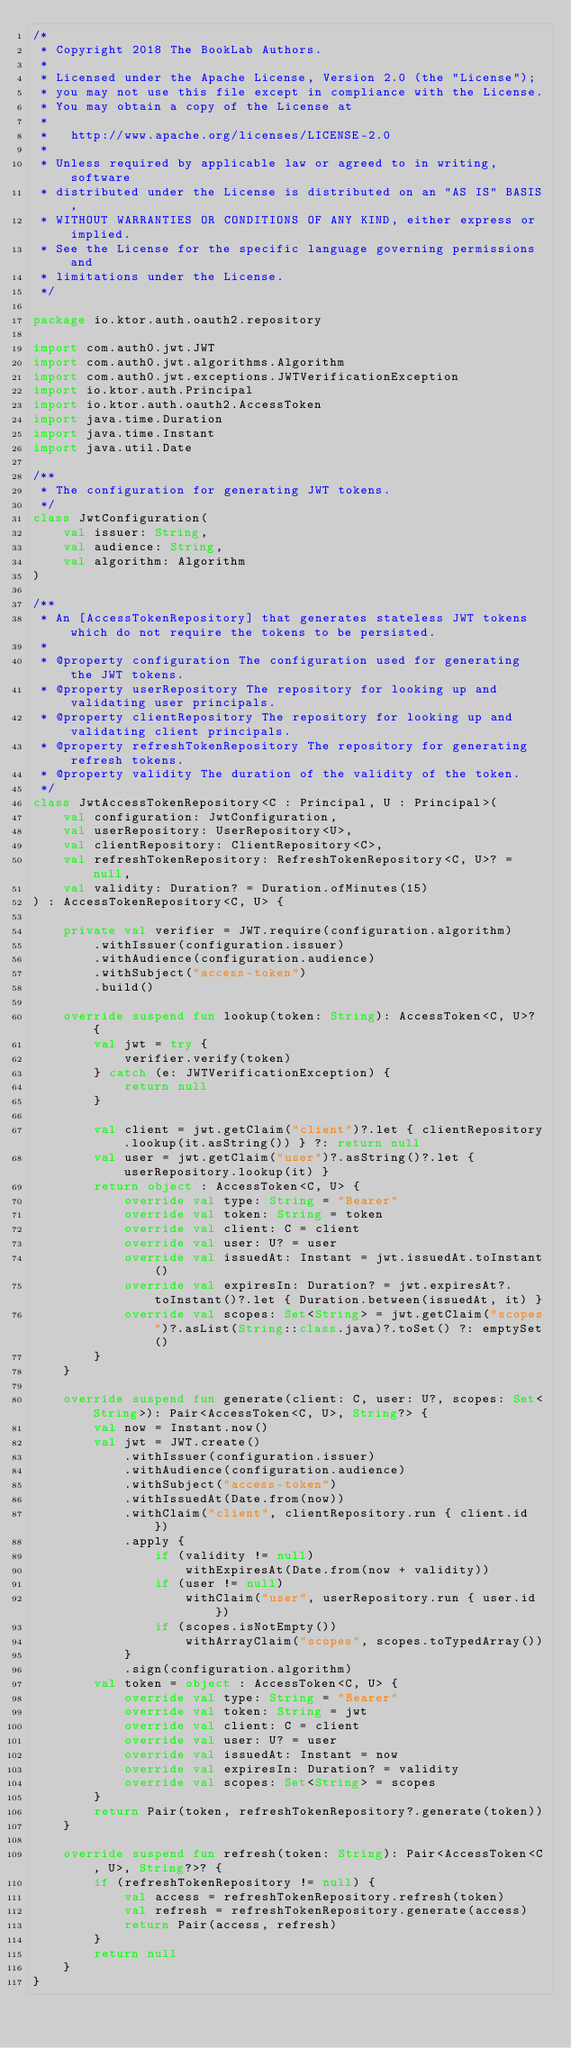<code> <loc_0><loc_0><loc_500><loc_500><_Kotlin_>/*
 * Copyright 2018 The BookLab Authors.
 *
 * Licensed under the Apache License, Version 2.0 (the "License");
 * you may not use this file except in compliance with the License.
 * You may obtain a copy of the License at
 *
 *   http://www.apache.org/licenses/LICENSE-2.0
 *
 * Unless required by applicable law or agreed to in writing, software
 * distributed under the License is distributed on an "AS IS" BASIS,
 * WITHOUT WARRANTIES OR CONDITIONS OF ANY KIND, either express or implied.
 * See the License for the specific language governing permissions and
 * limitations under the License.
 */

package io.ktor.auth.oauth2.repository

import com.auth0.jwt.JWT
import com.auth0.jwt.algorithms.Algorithm
import com.auth0.jwt.exceptions.JWTVerificationException
import io.ktor.auth.Principal
import io.ktor.auth.oauth2.AccessToken
import java.time.Duration
import java.time.Instant
import java.util.Date

/**
 * The configuration for generating JWT tokens.
 */
class JwtConfiguration(
    val issuer: String,
    val audience: String,
    val algorithm: Algorithm
)

/**
 * An [AccessTokenRepository] that generates stateless JWT tokens which do not require the tokens to be persisted.
 *
 * @property configuration The configuration used for generating the JWT tokens.
 * @property userRepository The repository for looking up and validating user principals.
 * @property clientRepository The repository for looking up and validating client principals.
 * @property refreshTokenRepository The repository for generating refresh tokens.
 * @property validity The duration of the validity of the token.
 */
class JwtAccessTokenRepository<C : Principal, U : Principal>(
    val configuration: JwtConfiguration,
    val userRepository: UserRepository<U>,
    val clientRepository: ClientRepository<C>,
    val refreshTokenRepository: RefreshTokenRepository<C, U>? = null,
    val validity: Duration? = Duration.ofMinutes(15)
) : AccessTokenRepository<C, U> {

    private val verifier = JWT.require(configuration.algorithm)
        .withIssuer(configuration.issuer)
        .withAudience(configuration.audience)
        .withSubject("access-token")
        .build()

    override suspend fun lookup(token: String): AccessToken<C, U>? {
        val jwt = try {
            verifier.verify(token)
        } catch (e: JWTVerificationException) {
            return null
        }

        val client = jwt.getClaim("client")?.let { clientRepository.lookup(it.asString()) } ?: return null
        val user = jwt.getClaim("user")?.asString()?.let { userRepository.lookup(it) }
        return object : AccessToken<C, U> {
            override val type: String = "Bearer"
            override val token: String = token
            override val client: C = client
            override val user: U? = user
            override val issuedAt: Instant = jwt.issuedAt.toInstant()
            override val expiresIn: Duration? = jwt.expiresAt?.toInstant()?.let { Duration.between(issuedAt, it) }
            override val scopes: Set<String> = jwt.getClaim("scopes")?.asList(String::class.java)?.toSet() ?: emptySet()
        }
    }

    override suspend fun generate(client: C, user: U?, scopes: Set<String>): Pair<AccessToken<C, U>, String?> {
        val now = Instant.now()
        val jwt = JWT.create()
            .withIssuer(configuration.issuer)
            .withAudience(configuration.audience)
            .withSubject("access-token")
            .withIssuedAt(Date.from(now))
            .withClaim("client", clientRepository.run { client.id })
            .apply {
                if (validity != null)
                    withExpiresAt(Date.from(now + validity))
                if (user != null)
                    withClaim("user", userRepository.run { user.id })
                if (scopes.isNotEmpty())
                    withArrayClaim("scopes", scopes.toTypedArray())
            }
            .sign(configuration.algorithm)
        val token = object : AccessToken<C, U> {
            override val type: String = "Bearer"
            override val token: String = jwt
            override val client: C = client
            override val user: U? = user
            override val issuedAt: Instant = now
            override val expiresIn: Duration? = validity
            override val scopes: Set<String> = scopes
        }
        return Pair(token, refreshTokenRepository?.generate(token))
    }

    override suspend fun refresh(token: String): Pair<AccessToken<C, U>, String?>? {
        if (refreshTokenRepository != null) {
            val access = refreshTokenRepository.refresh(token)
            val refresh = refreshTokenRepository.generate(access)
            return Pair(access, refresh)
        }
        return null
    }
}
</code> 